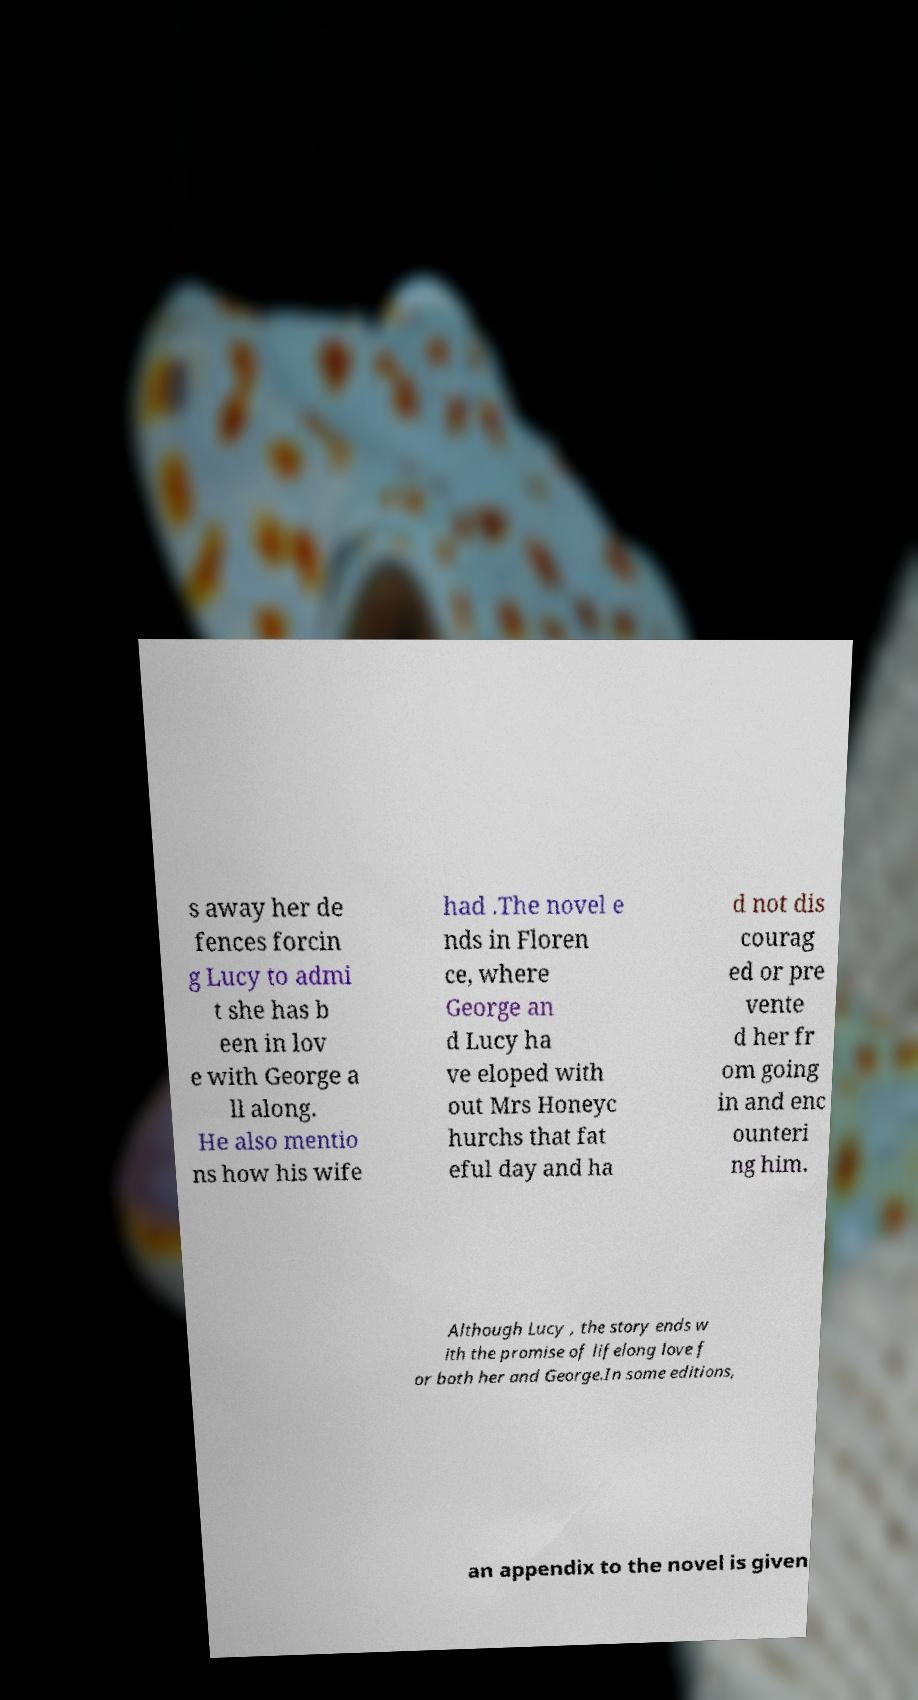Can you accurately transcribe the text from the provided image for me? s away her de fences forcin g Lucy to admi t she has b een in lov e with George a ll along. He also mentio ns how his wife had .The novel e nds in Floren ce, where George an d Lucy ha ve eloped with out Mrs Honeyc hurchs that fat eful day and ha d not dis courag ed or pre vente d her fr om going in and enc ounteri ng him. Although Lucy , the story ends w ith the promise of lifelong love f or both her and George.In some editions, an appendix to the novel is given 